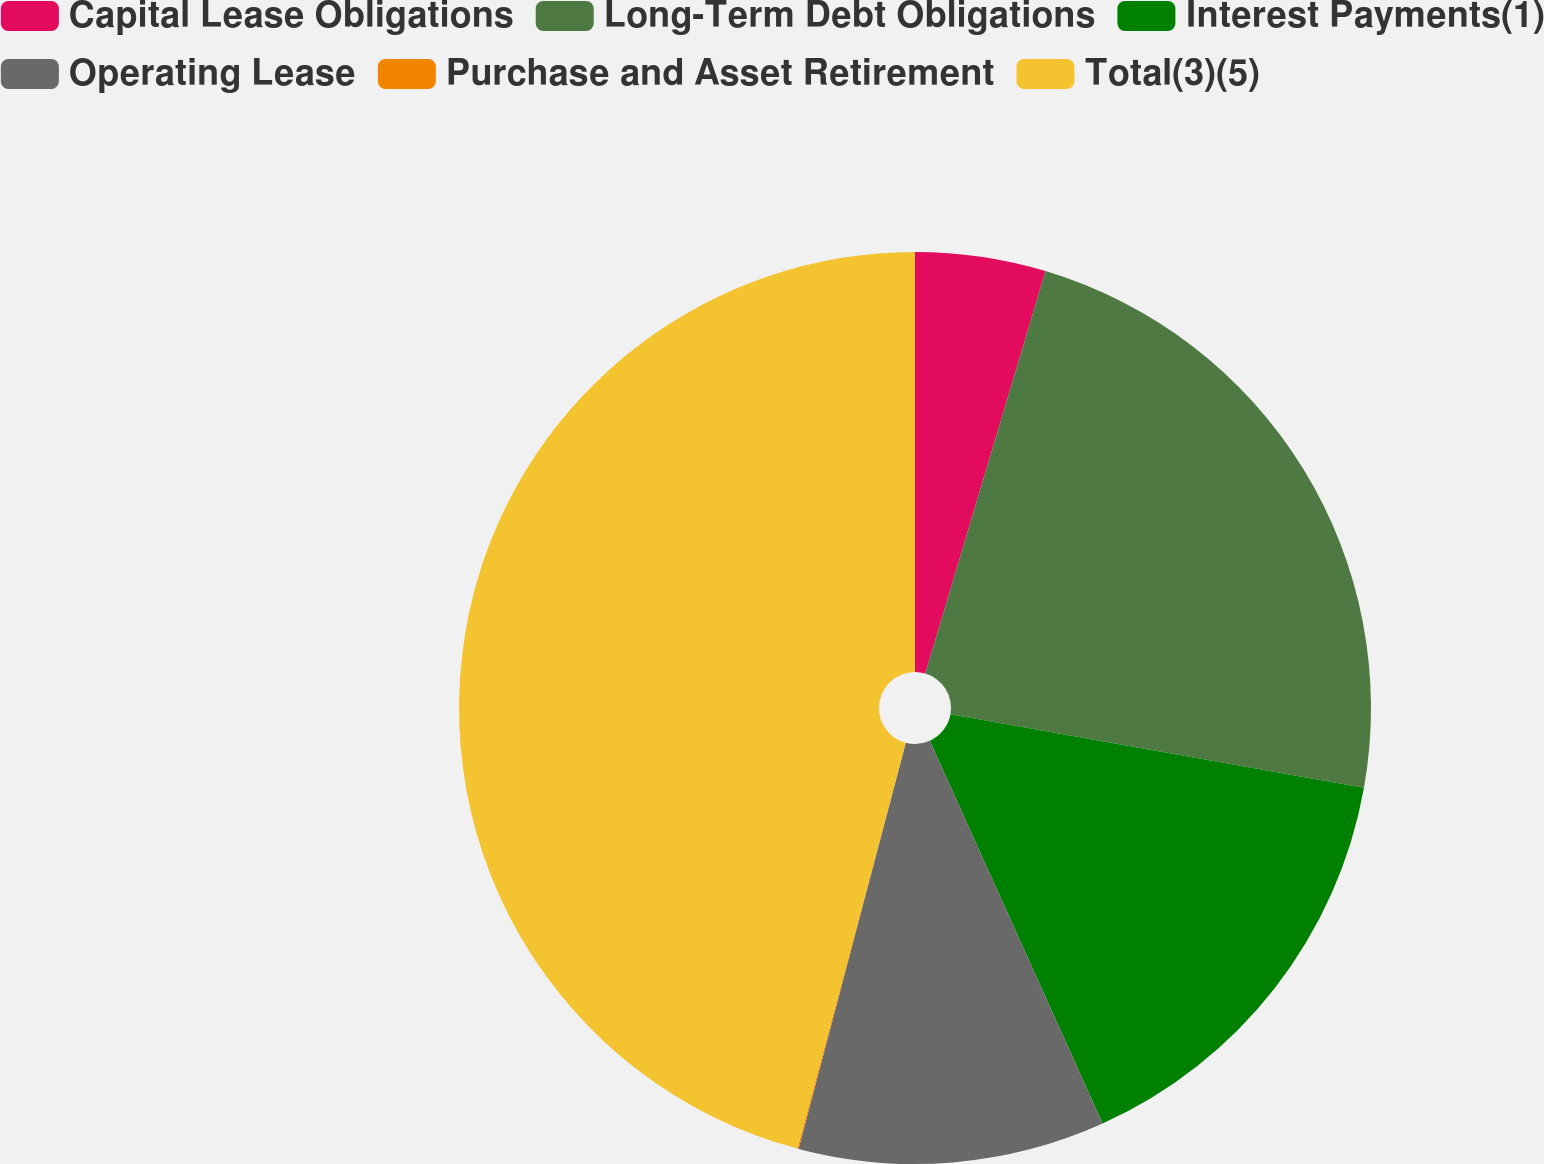Convert chart. <chart><loc_0><loc_0><loc_500><loc_500><pie_chart><fcel>Capital Lease Obligations<fcel>Long-Term Debt Obligations<fcel>Interest Payments(1)<fcel>Operating Lease<fcel>Purchase and Asset Retirement<fcel>Total(3)(5)<nl><fcel>4.62%<fcel>23.18%<fcel>15.45%<fcel>10.86%<fcel>0.04%<fcel>45.85%<nl></chart> 